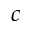<formula> <loc_0><loc_0><loc_500><loc_500>c</formula> 